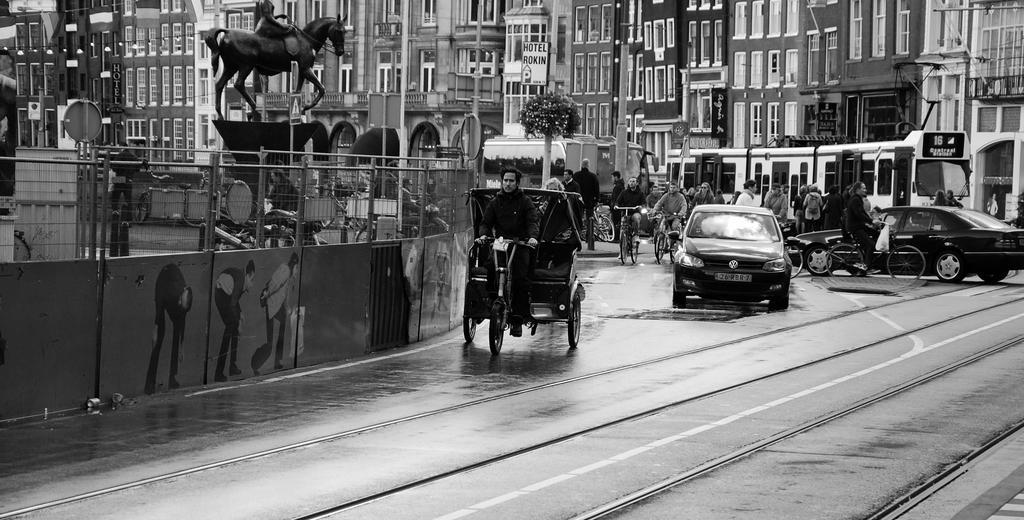Could you give a brief overview of what you see in this image? There is a road. On that there are cars, cycle rickshaws. In the back there is a tree. On the left side there is a wall with railings. Also there is statue. In the background there are buildings with windows. Also there is a tree. 